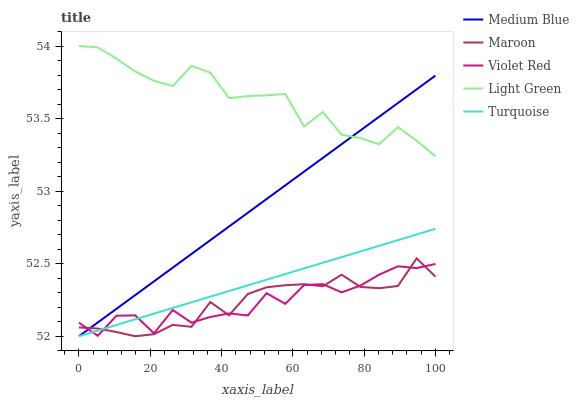Does Maroon have the minimum area under the curve?
Answer yes or no. Yes. Does Light Green have the maximum area under the curve?
Answer yes or no. Yes. Does Turquoise have the minimum area under the curve?
Answer yes or no. No. Does Turquoise have the maximum area under the curve?
Answer yes or no. No. Is Turquoise the smoothest?
Answer yes or no. Yes. Is Violet Red the roughest?
Answer yes or no. Yes. Is Medium Blue the smoothest?
Answer yes or no. No. Is Medium Blue the roughest?
Answer yes or no. No. Does Light Green have the lowest value?
Answer yes or no. No. Does Light Green have the highest value?
Answer yes or no. Yes. Does Turquoise have the highest value?
Answer yes or no. No. Is Turquoise less than Light Green?
Answer yes or no. Yes. Is Light Green greater than Maroon?
Answer yes or no. Yes. Does Turquoise intersect Violet Red?
Answer yes or no. Yes. Is Turquoise less than Violet Red?
Answer yes or no. No. Is Turquoise greater than Violet Red?
Answer yes or no. No. Does Turquoise intersect Light Green?
Answer yes or no. No. 